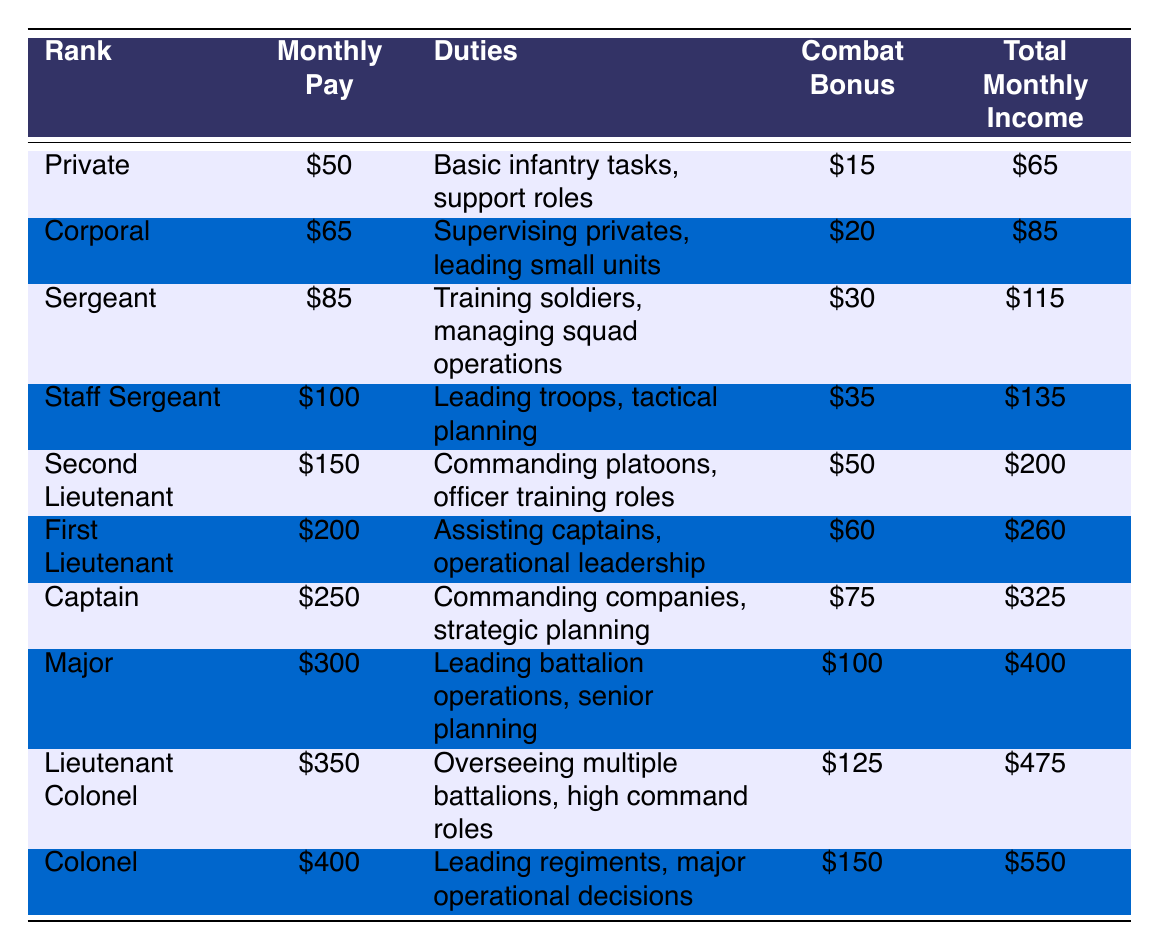What is the total monthly income for a Corporal? The table states that the total monthly income for a Corporal is listed directly under the "Total Monthly Income" column, which shows $85.
Answer: $85 How much more does a Captain earn compared to a Private? The monthly pay for Captain is $250 and for Private is $50. The difference is calculated as $250 - $50 = $200.
Answer: $200 Is the combat bonus for a Second Lieutenant greater than that of a Staff Sergeant? According to the table, the combat bonus for a Second Lieutenant is $50 and for a Staff Sergeant is $35. Since $50 is greater than $35, the answer is yes.
Answer: Yes What is the average monthly pay for the ranks listed? First, sum up the monthly pay: $50 + $65 + $85 + $100 + $150 + $200 + $250 + $300 + $350 + $400 = $1950. Then, divide by the number of ranks, which is 10: $1950 / 10 = $195.
Answer: $195 Which rank has the highest total monthly income, and what is that amount? By scanning the "Total Monthly Income" column, it shows that Colonel has the highest amount of $550, compared to other ranks.
Answer: $550 How does the total monthly income of a Major compare to that of a Lieutenant Colonel? The total monthly income for Major is $400 and for Lieutenant Colonel is $475. Since $400 is less than $475, the Major earns less.
Answer: Major earns less What percentage of a Captain's total monthly income comes from their combat bonus? To find this, divide Captain's combat bonus $75 by their total monthly income $325, then multiply by 100: ($75 / $325) * 100 = 23.08%.
Answer: Approximately 23.08% Which rank has the lowest monthly pay, and how much is it? Looking at the "Monthly Pay" column, Private has the lowest amount, which is $50.
Answer: $50 If someone desires a role that involves tactical planning and aims for the highest monthly income, which rank should they pursue? The role involving tactical planning is noted under Staff Sergeant, which has a total income of $135, but for the highest income, the rank to pursue is Colonel with $550.
Answer: Colonel Are there more ranks that have a combat bonus of $30 or less than ranks that have more than $30? Reviewing the combat bonuses, those with $30 or less are Private ($15), Corporal ($20), and Sergeant ($30) totaling 3 ranks. The ranks with more than $30 are Staff Sergeant, Second Lieutenant, First Lieutenant, Captain, Major, Lieutenant Colonel, and Colonel totaling 7 ranks. Therefore, there are more ranks with more than $30.
Answer: More ranks have more than $30 